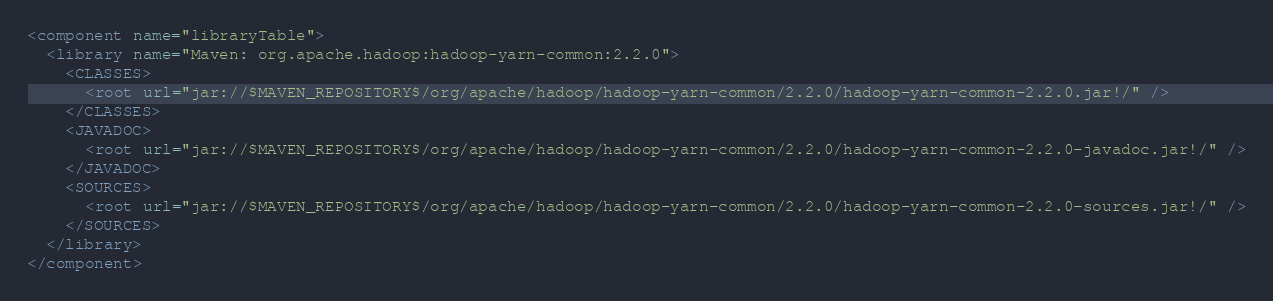<code> <loc_0><loc_0><loc_500><loc_500><_XML_><component name="libraryTable">
  <library name="Maven: org.apache.hadoop:hadoop-yarn-common:2.2.0">
    <CLASSES>
      <root url="jar://$MAVEN_REPOSITORY$/org/apache/hadoop/hadoop-yarn-common/2.2.0/hadoop-yarn-common-2.2.0.jar!/" />
    </CLASSES>
    <JAVADOC>
      <root url="jar://$MAVEN_REPOSITORY$/org/apache/hadoop/hadoop-yarn-common/2.2.0/hadoop-yarn-common-2.2.0-javadoc.jar!/" />
    </JAVADOC>
    <SOURCES>
      <root url="jar://$MAVEN_REPOSITORY$/org/apache/hadoop/hadoop-yarn-common/2.2.0/hadoop-yarn-common-2.2.0-sources.jar!/" />
    </SOURCES>
  </library>
</component></code> 